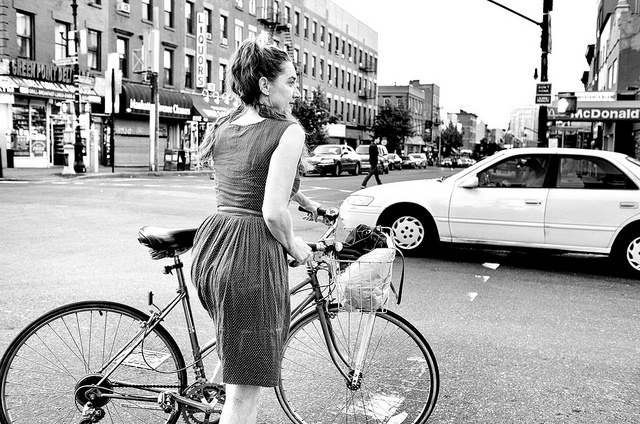Read all the text in this image. GREEN McDonald LIQUORS 